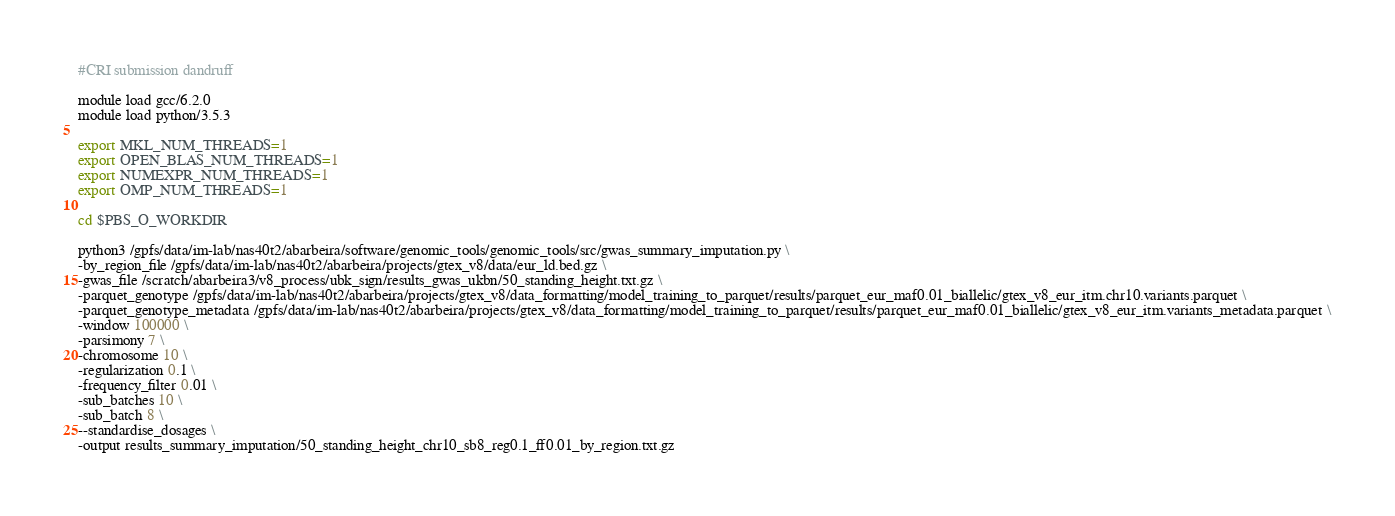<code> <loc_0><loc_0><loc_500><loc_500><_Bash_>#CRI submission dandruff

module load gcc/6.2.0
module load python/3.5.3

export MKL_NUM_THREADS=1
export OPEN_BLAS_NUM_THREADS=1
export NUMEXPR_NUM_THREADS=1
export OMP_NUM_THREADS=1

cd $PBS_O_WORKDIR

python3 /gpfs/data/im-lab/nas40t2/abarbeira/software/genomic_tools/genomic_tools/src/gwas_summary_imputation.py \
-by_region_file /gpfs/data/im-lab/nas40t2/abarbeira/projects/gtex_v8/data/eur_ld.bed.gz \
-gwas_file /scratch/abarbeira3/v8_process/ubk_sign/results_gwas_ukbn/50_standing_height.txt.gz \
-parquet_genotype /gpfs/data/im-lab/nas40t2/abarbeira/projects/gtex_v8/data_formatting/model_training_to_parquet/results/parquet_eur_maf0.01_biallelic/gtex_v8_eur_itm.chr10.variants.parquet \
-parquet_genotype_metadata /gpfs/data/im-lab/nas40t2/abarbeira/projects/gtex_v8/data_formatting/model_training_to_parquet/results/parquet_eur_maf0.01_biallelic/gtex_v8_eur_itm.variants_metadata.parquet \
-window 100000 \
-parsimony 7 \
-chromosome 10 \
-regularization 0.1 \
-frequency_filter 0.01 \
-sub_batches 10 \
-sub_batch 8 \
--standardise_dosages \
-output results_summary_imputation/50_standing_height_chr10_sb8_reg0.1_ff0.01_by_region.txt.gz</code> 